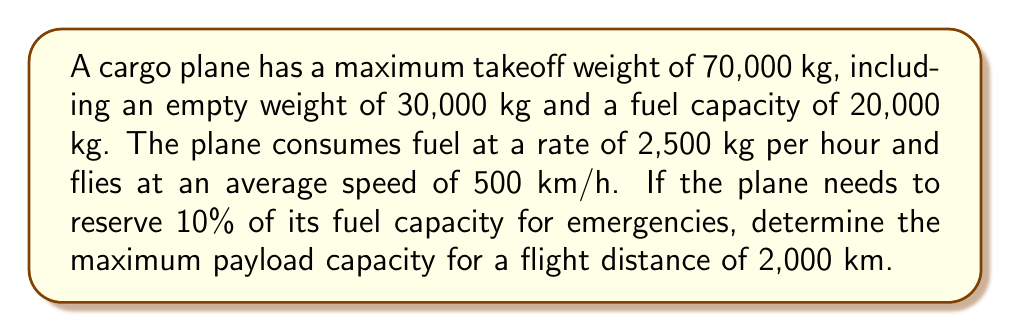Could you help me with this problem? Let's approach this problem step-by-step:

1) First, let's calculate the flight time:
   $$\text{Flight time} = \frac{\text{Distance}}{\text{Speed}} = \frac{2000 \text{ km}}{500 \text{ km/h}} = 4 \text{ hours}$$

2) Now, let's calculate the fuel consumption for the flight:
   $$\text{Fuel consumed} = \text{Fuel consumption rate} \times \text{Flight time}$$
   $$\text{Fuel consumed} = 2500 \text{ kg/h} \times 4 \text{ h} = 10000 \text{ kg}$$

3) We need to add 10% of the fuel capacity for emergencies:
   $$\text{Emergency fuel} = 10\% \times 20000 \text{ kg} = 2000 \text{ kg}$$

4) Total fuel required:
   $$\text{Total fuel} = \text{Fuel consumed} + \text{Emergency fuel} = 10000 \text{ kg} + 2000 \text{ kg} = 12000 \text{ kg}$$

5) Now, let's calculate the available weight for payload:
   $$\text{Available weight} = \text{Max takeoff weight} - \text{Empty weight} - \text{Total fuel}$$
   $$\text{Available weight} = 70000 \text{ kg} - 30000 \text{ kg} - 12000 \text{ kg} = 28000 \text{ kg}$$

Therefore, the maximum payload capacity for a 2,000 km flight is 28,000 kg.
Answer: 28,000 kg 